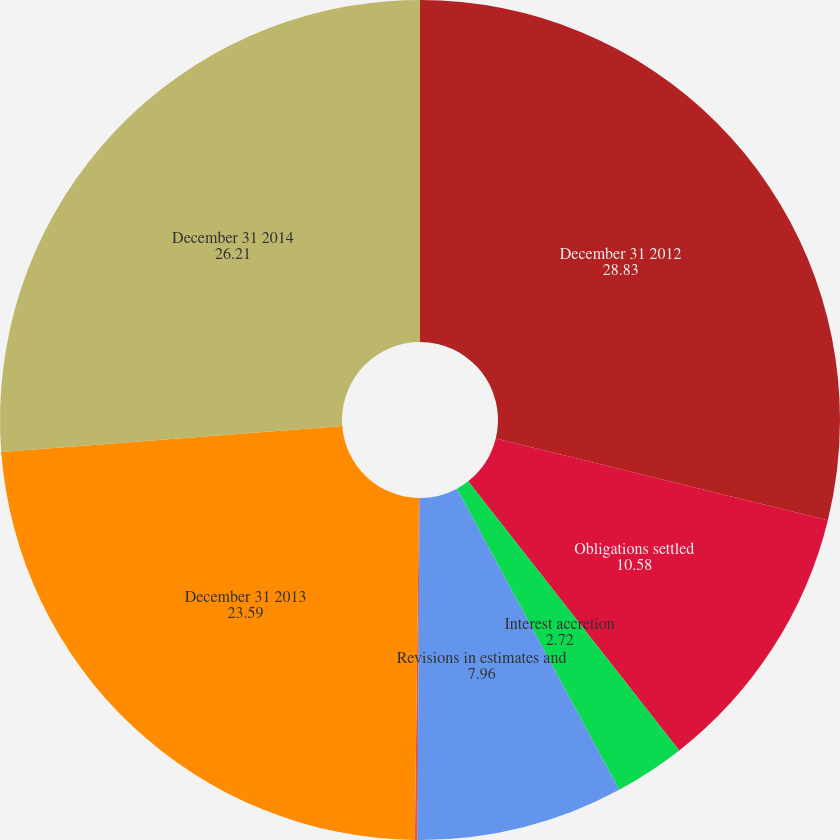Convert chart to OTSL. <chart><loc_0><loc_0><loc_500><loc_500><pie_chart><fcel>December 31 2012<fcel>Obligations settled<fcel>Interest accretion<fcel>Revisions in estimates and<fcel>Acquisitions divestitures and<fcel>December 31 2013<fcel>December 31 2014<nl><fcel>28.83%<fcel>10.58%<fcel>2.72%<fcel>7.96%<fcel>0.1%<fcel>23.59%<fcel>26.21%<nl></chart> 